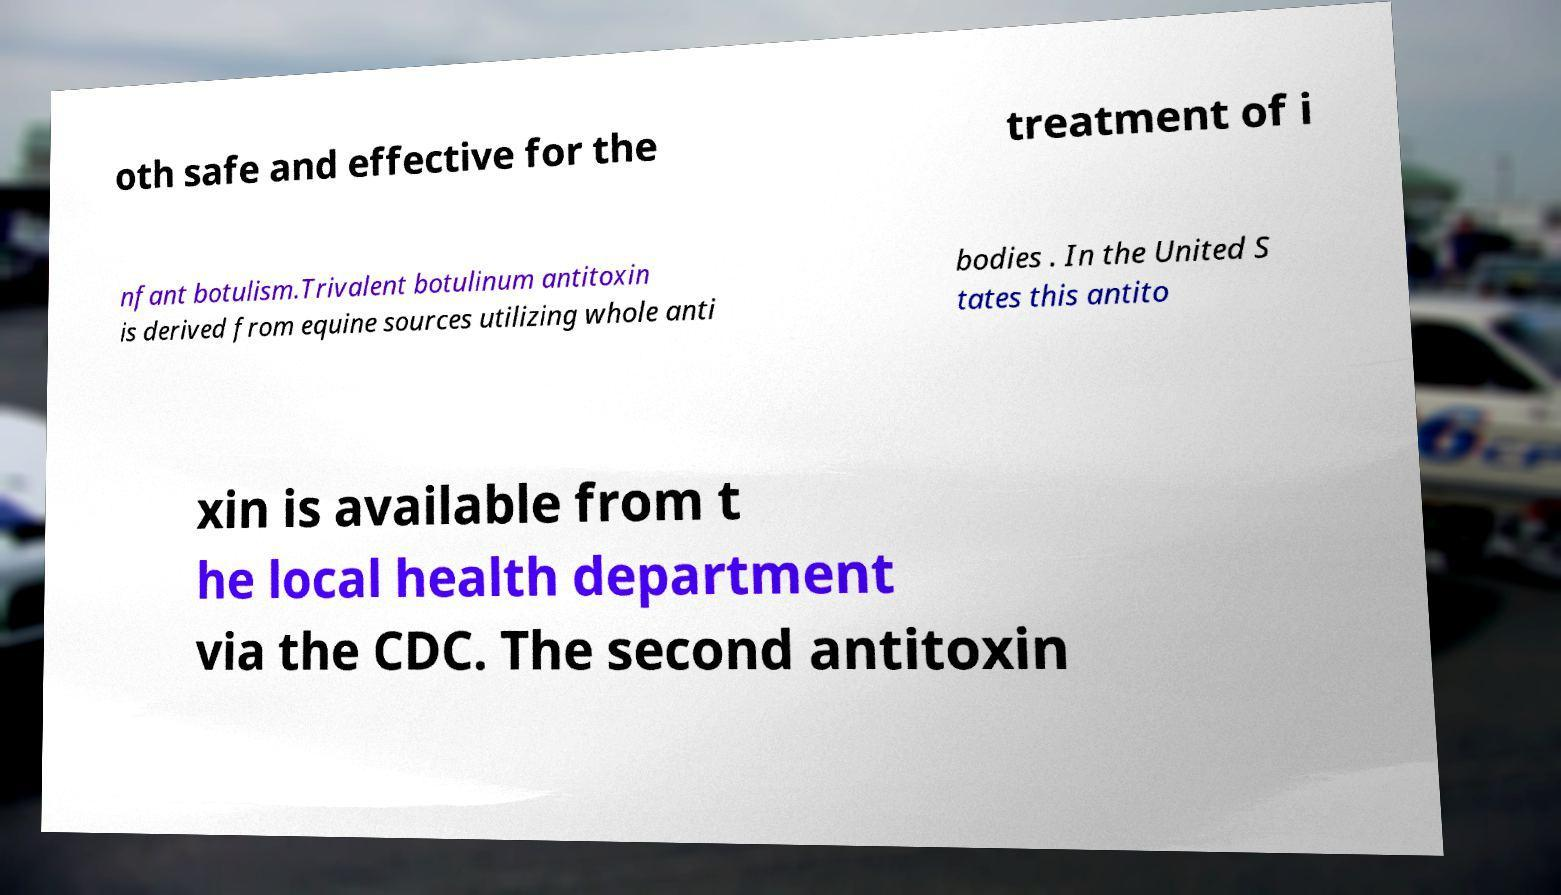There's text embedded in this image that I need extracted. Can you transcribe it verbatim? oth safe and effective for the treatment of i nfant botulism.Trivalent botulinum antitoxin is derived from equine sources utilizing whole anti bodies . In the United S tates this antito xin is available from t he local health department via the CDC. The second antitoxin 